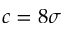Convert formula to latex. <formula><loc_0><loc_0><loc_500><loc_500>c = 8 \sigma</formula> 